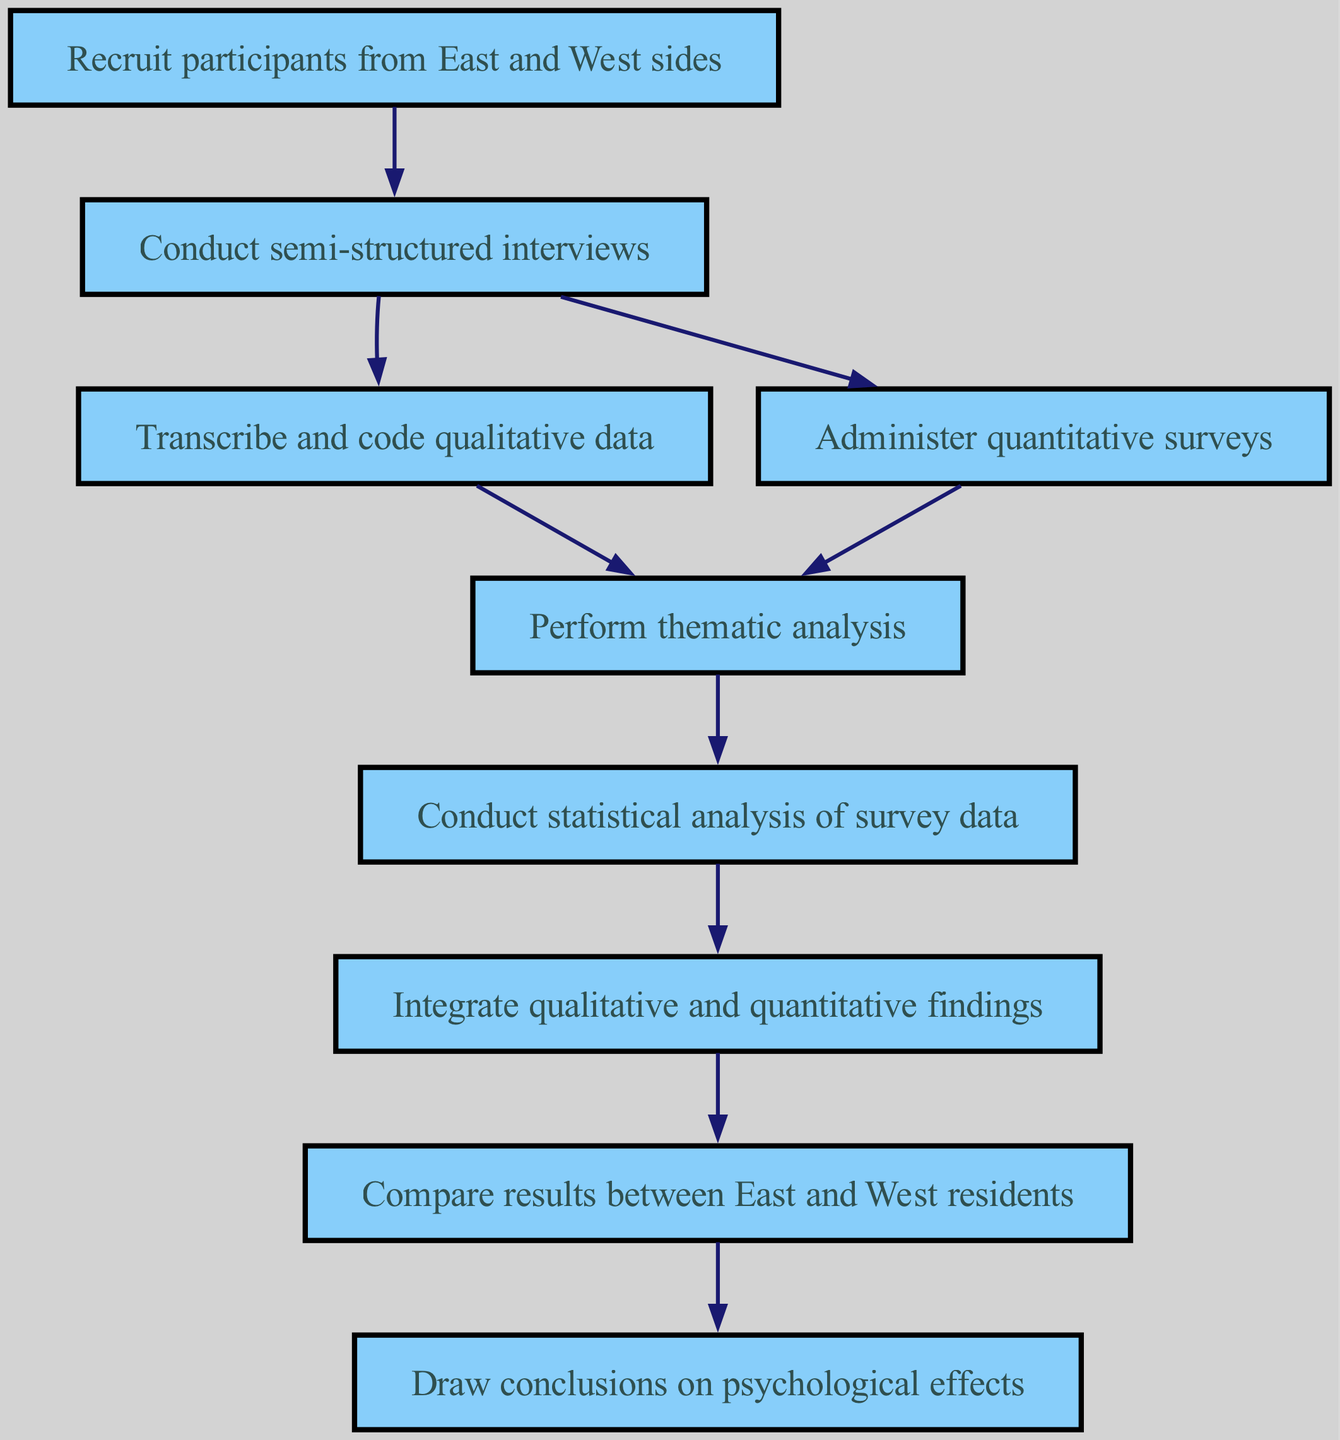What is the first step in the diagram? The first step outlined in the diagram is to recruit participants from both the East and West sides. This is indicated as the starting element in the flow chart, which leads to the next step of conducting interviews.
Answer: Recruit participants from East and West sides How many total nodes are in the diagram? By counting each distinct step or node from the beginning to the end of the diagram, there are a total of nine nodes listed throughout the instruction flow.
Answer: Nine What type of analysis follows after the thematic analysis? After conducting the thematic analysis, which examines patterns within qualitative data, the next step is to conduct a statistical analysis of survey data, showcasing the transition from qualitative to quantitative analysis.
Answer: Conduct statistical analysis of survey data Which steps can be conducted in parallel? The semi-structured interviews and the quantitative surveys can be performed concurrently, as indicated by their direct branching from the same node without hierarchical ordering.
Answer: Conduct semi-structured interviews and administer quantitative surveys What is the final conclusion drawn about the psychological effects of living in a divided city? The ultimate conclusion drawn from the analysis process integrates all findings and focuses on understanding the psychological effects specifically experienced by residents in a divided city. This follows the comparative evaluation of results from East and West sides.
Answer: Draw conclusions on psychological effects What connects the second and third nodes in the diagram? The second node about conducting semi-structured interviews directly transitions to both the third node on transcribing qualitative data and the fourth node on administering quantitative surveys, showing that each of these analyses follows from the interviews.
Answer: Semi-structured interviews At which point do qualitative and quantitative findings integrate? The integration of qualitative and quantitative findings occurs at the seventh node in the flow, where the results from analyses of both types of data are brought together for comprehensive understanding.
Answer: Integrate qualitative and quantitative findings 